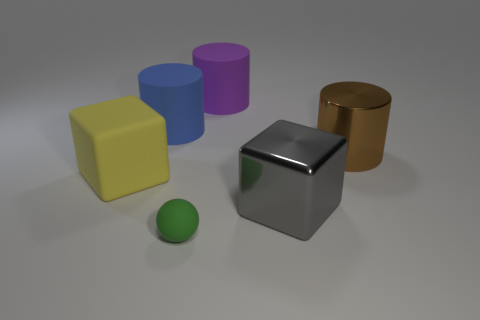Is the number of big brown objects on the left side of the blue object greater than the number of yellow cubes that are to the left of the large yellow rubber object? No, the number of big brown objects on the left side of the blue object, which is one, is not greater than the number of yellow cubes to the left of the large yellow rubber object because there are no yellow cubes to the left of the yellow rubber object. The only cube present is a yellow one located to the right of the large yellow object. 